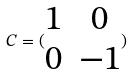<formula> <loc_0><loc_0><loc_500><loc_500>C = ( \begin{matrix} 1 & 0 \\ 0 & - 1 \end{matrix} )</formula> 